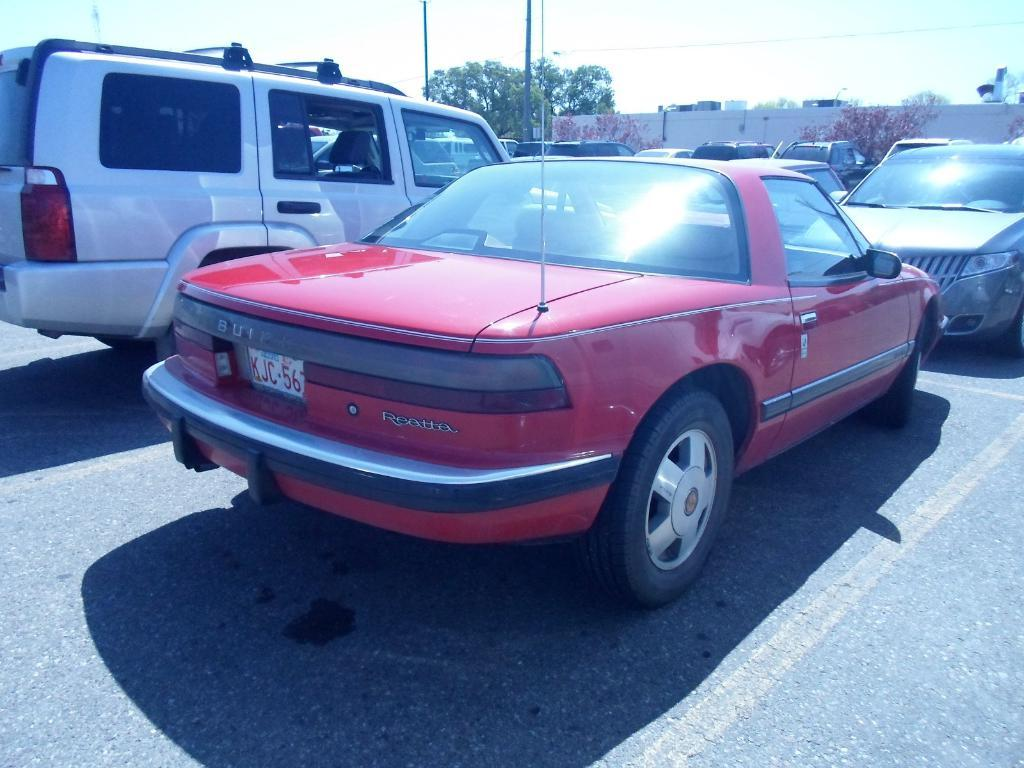What can be seen in the image? There are vehicles in the image. What is visible in the background of the image? There are trees, a building, two poles, a wire, and the sky visible in the background of the image. Can you see any feathers floating in the air in the image? There are no feathers visible in the image. How do the poles maintain their balance in the image? The poles do not need to maintain balance in the image, as they are stationary and not moving. 